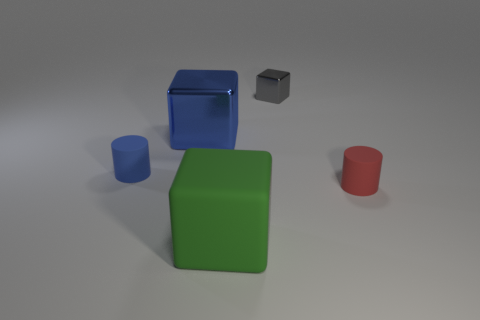How many small objects are the same color as the big metal thing?
Offer a very short reply. 1. Does the tiny cylinder on the left side of the red matte thing have the same color as the large metal cube?
Your answer should be very brief. Yes. Are any small yellow matte cylinders visible?
Ensure brevity in your answer.  No. How many other things are the same size as the red matte object?
Make the answer very short. 2. Is the color of the big thing behind the green block the same as the small thing on the left side of the large green rubber thing?
Keep it short and to the point. Yes. The green rubber thing that is the same shape as the small gray thing is what size?
Offer a very short reply. Large. Does the tiny cylinder behind the small red object have the same material as the big cube that is behind the blue matte cylinder?
Your response must be concise. No. How many metallic objects are either large things or brown cubes?
Provide a short and direct response. 1. There is a big block that is to the left of the block that is in front of the cube to the left of the green object; what is it made of?
Your answer should be compact. Metal. There is a shiny object on the left side of the rubber cube; is its shape the same as the big object in front of the blue rubber object?
Offer a very short reply. Yes. 